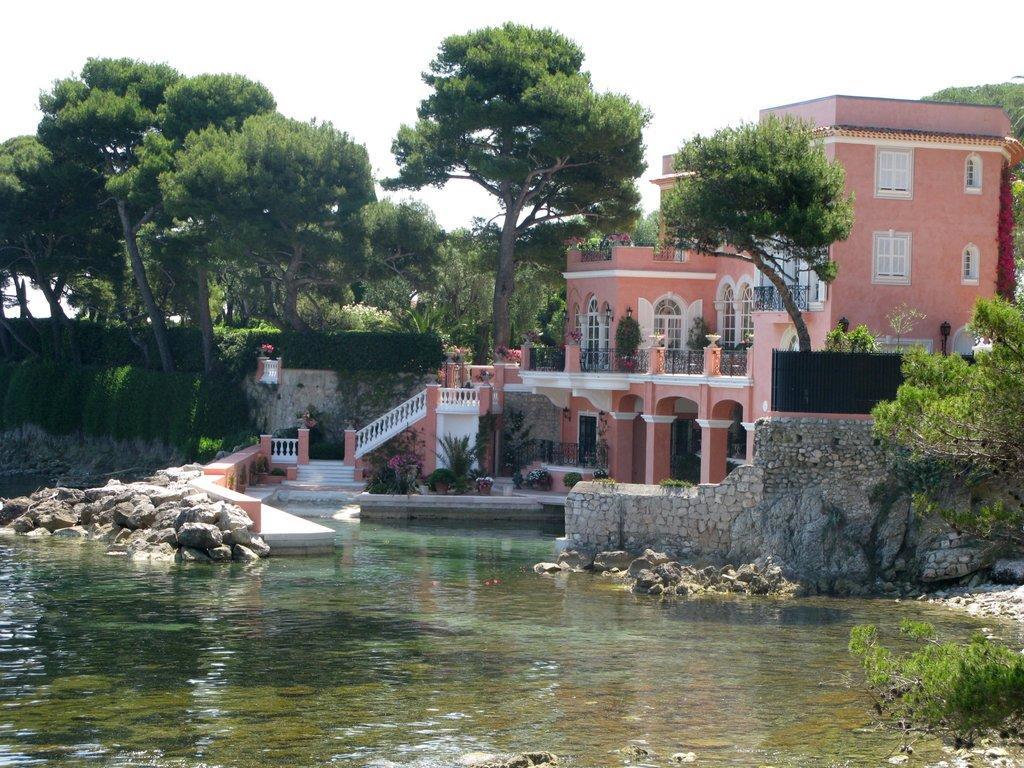Please provide a concise description of this image. In this image in front there is water. There are rocks. There is a wall. There are flower pots. In the background of the image there are buildings, trees and sky. 